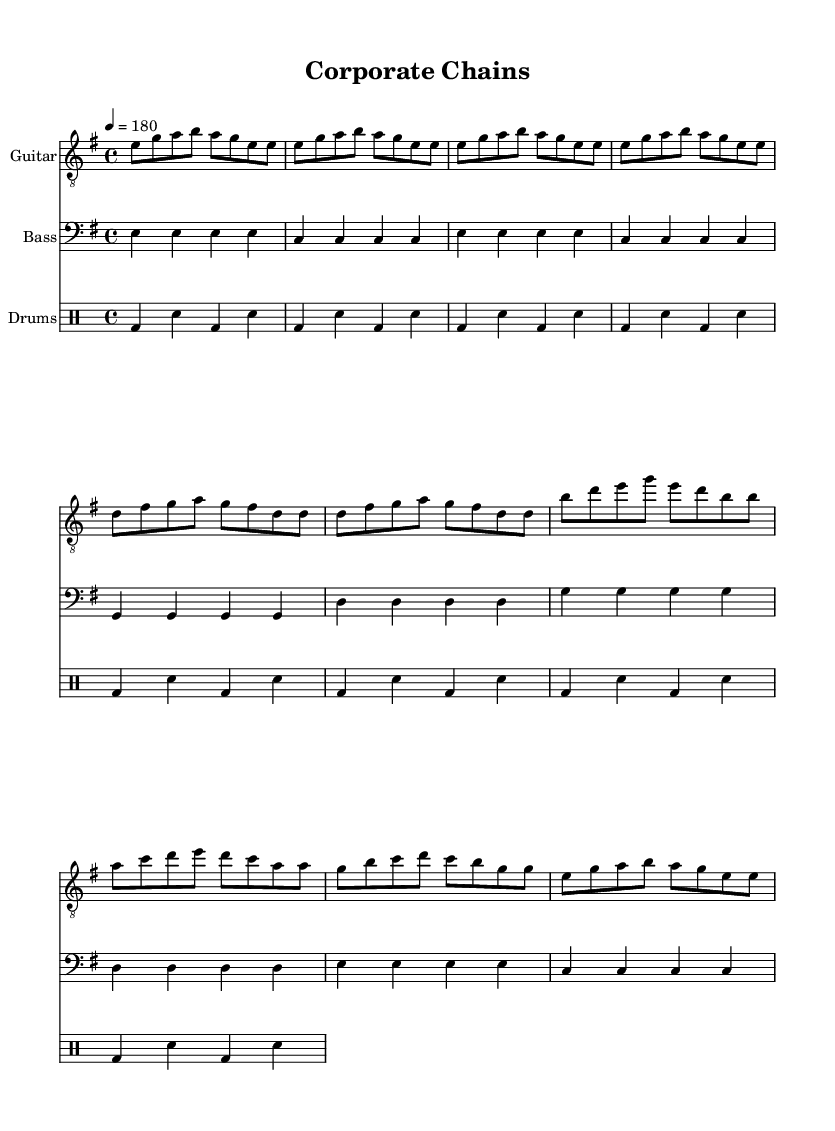What is the key signature of this music? The key signature is indicated as E minor, which is characterized by one sharp (F#). This can be deduced from the global section at the beginning of the code where it states "\key e \minor".
Answer: E minor What is the time signature of this music? The time signature is specified as 4/4, which means there are four beats in each measure and the quarter note gets one beat. This is found in the global section of the code that states "\time 4/4".
Answer: 4/4 What is the tempo marking for this piece? The tempo marking is given as a quarter note equals 180 beats per minute, which means the music should be played quite quickly. This is indicated in the global section with the command "\tempo 4 = 180".
Answer: 180 How many measures are in the chorus? The chorus consists of 4 measures, each containing various note values as specified in the chorus section of the music. Each line is counted as one measure and there are four distinct lines in the chorus section.
Answer: 4 What is a defining characteristic of the drum pattern in this sheet music? The defining characteristic of the drum pattern is the standard punk beat, which is repetitive and energetic, indicated by the alternating bass and snare drum hits throughout. This style is a signature of the punk genre.
Answer: Standard punk beat What are the lyrics of the chorus emphasizing? The lyrics of the chorus emphasize rebellion against corporate control, with phrases indicating breaking free from corporate chains and rejecting being mindless drones. This thematic element is common in punk music that critiques corporate culture.
Answer: Rebellion against corporate control What type of instruments are used in this score? The instruments used in this score are guitar, bass, and drums, which are typical for punk music, providing a classic punk sound that emphasizes rhythm and attitude. This can be noted from the staff labels in the score.
Answer: Guitar, bass, drums 